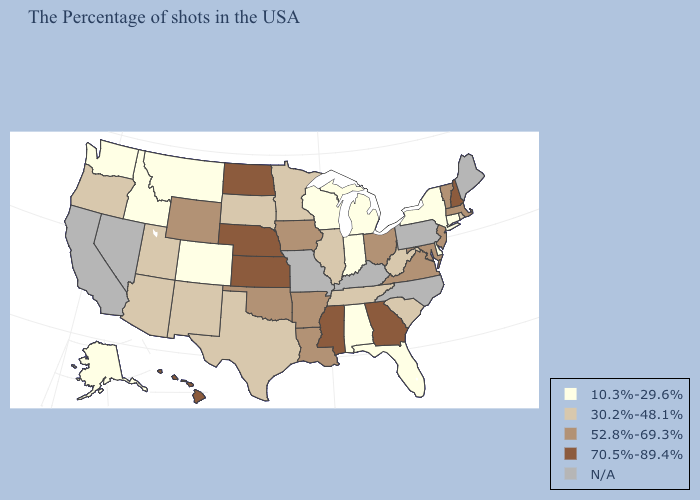Does Washington have the highest value in the USA?
Concise answer only. No. Does Hawaii have the highest value in the West?
Keep it brief. Yes. Does Maryland have the highest value in the USA?
Concise answer only. No. Name the states that have a value in the range 10.3%-29.6%?
Answer briefly. Connecticut, New York, Delaware, Florida, Michigan, Indiana, Alabama, Wisconsin, Colorado, Montana, Idaho, Washington, Alaska. Which states have the highest value in the USA?
Give a very brief answer. New Hampshire, Georgia, Mississippi, Kansas, Nebraska, North Dakota, Hawaii. What is the value of North Dakota?
Be succinct. 70.5%-89.4%. Does Mississippi have the highest value in the USA?
Quick response, please. Yes. What is the value of Michigan?
Be succinct. 10.3%-29.6%. Name the states that have a value in the range 52.8%-69.3%?
Concise answer only. Massachusetts, Vermont, New Jersey, Maryland, Virginia, Ohio, Louisiana, Arkansas, Iowa, Oklahoma, Wyoming. Which states have the lowest value in the South?
Short answer required. Delaware, Florida, Alabama. Does Maryland have the lowest value in the USA?
Quick response, please. No. What is the value of Tennessee?
Give a very brief answer. 30.2%-48.1%. Which states have the lowest value in the USA?
Keep it brief. Connecticut, New York, Delaware, Florida, Michigan, Indiana, Alabama, Wisconsin, Colorado, Montana, Idaho, Washington, Alaska. Name the states that have a value in the range 70.5%-89.4%?
Be succinct. New Hampshire, Georgia, Mississippi, Kansas, Nebraska, North Dakota, Hawaii. 